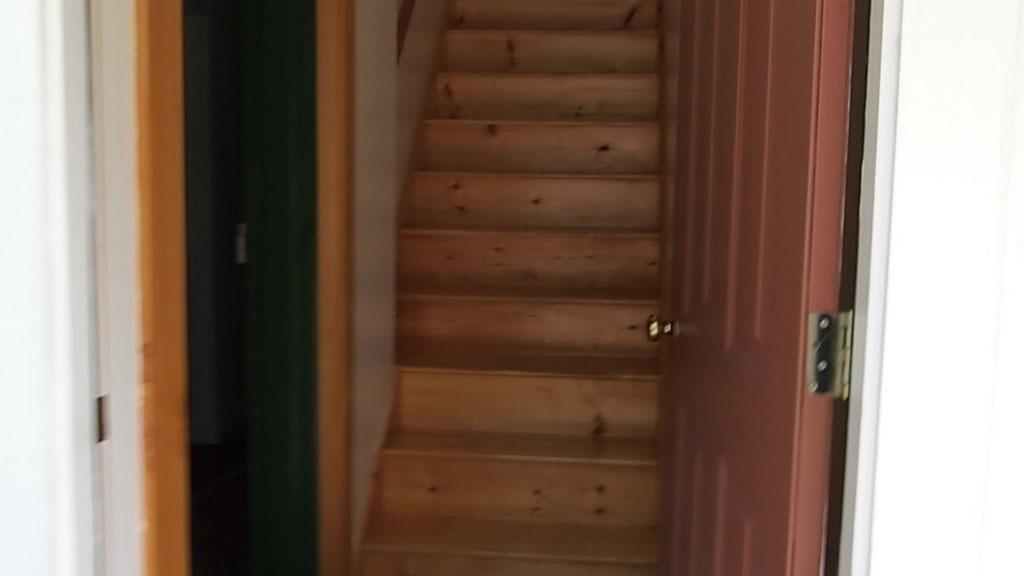What type of structure is present in the image? There is a step with a wall in the image. What is located near the step? There is a door with a handle beside the step. What material are the steps made of? The steps are made of wood. How many jellyfish can be seen swimming near the steps in the image? There are no jellyfish present in the image; it features a step with a wall and a door with a handle. 